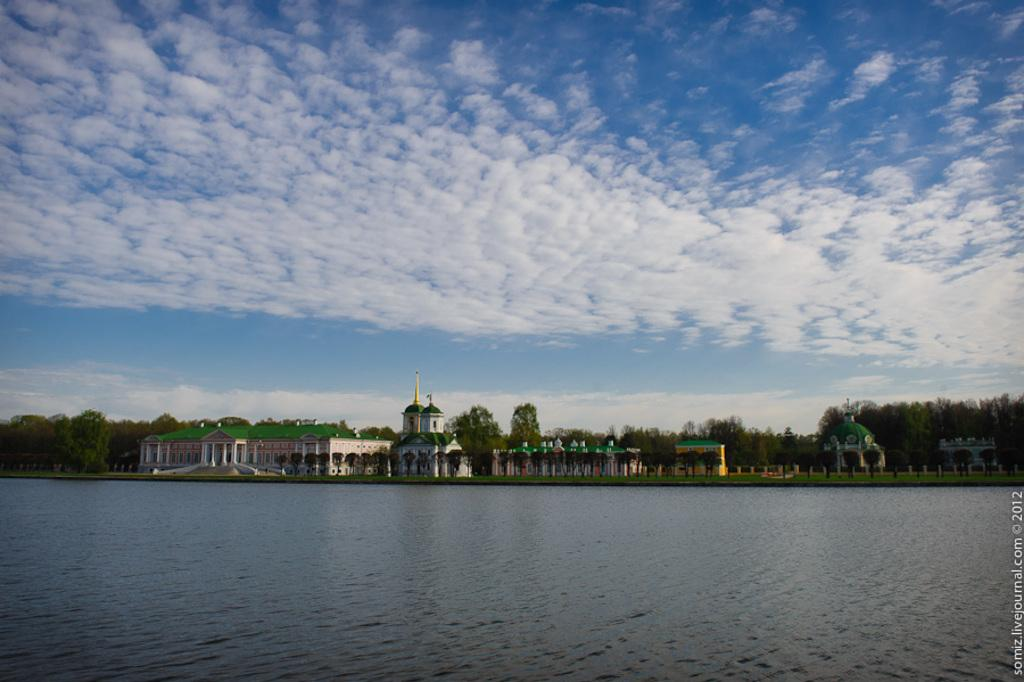What can be seen in the image that covers the ground? There is grass on the ground in the image. What is the primary liquid visible in the image? There is water visible in the image. How are the buildings in the image distinguished by color? Some of the buildings in the image are white and green in color. What type of vegetation is visible in the background of the image? There are trees in the background of the image. What part of the natural environment is visible in the image? The sky is visible in the background of the image. What type of reason can be seen growing on top of the buildings in the image? There is no reason visible in the image, and the buildings do not have anything growing on top of them. 